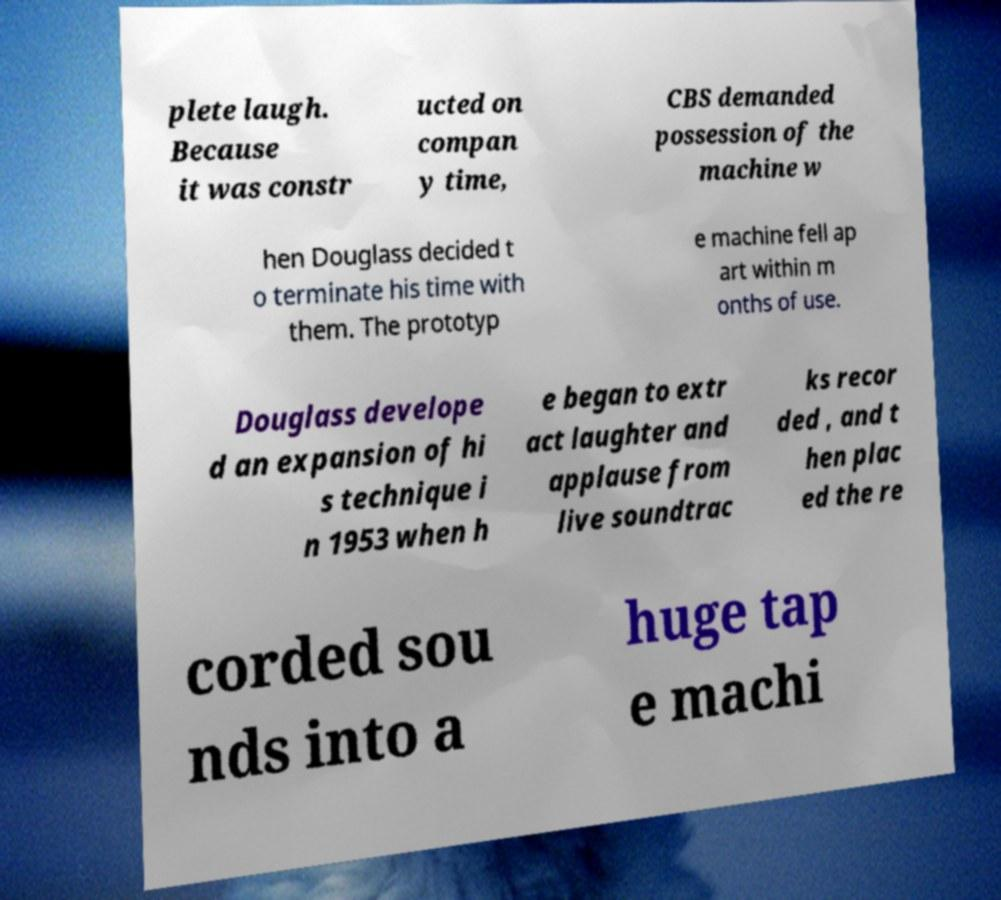Please identify and transcribe the text found in this image. plete laugh. Because it was constr ucted on compan y time, CBS demanded possession of the machine w hen Douglass decided t o terminate his time with them. The prototyp e machine fell ap art within m onths of use. Douglass develope d an expansion of hi s technique i n 1953 when h e began to extr act laughter and applause from live soundtrac ks recor ded , and t hen plac ed the re corded sou nds into a huge tap e machi 